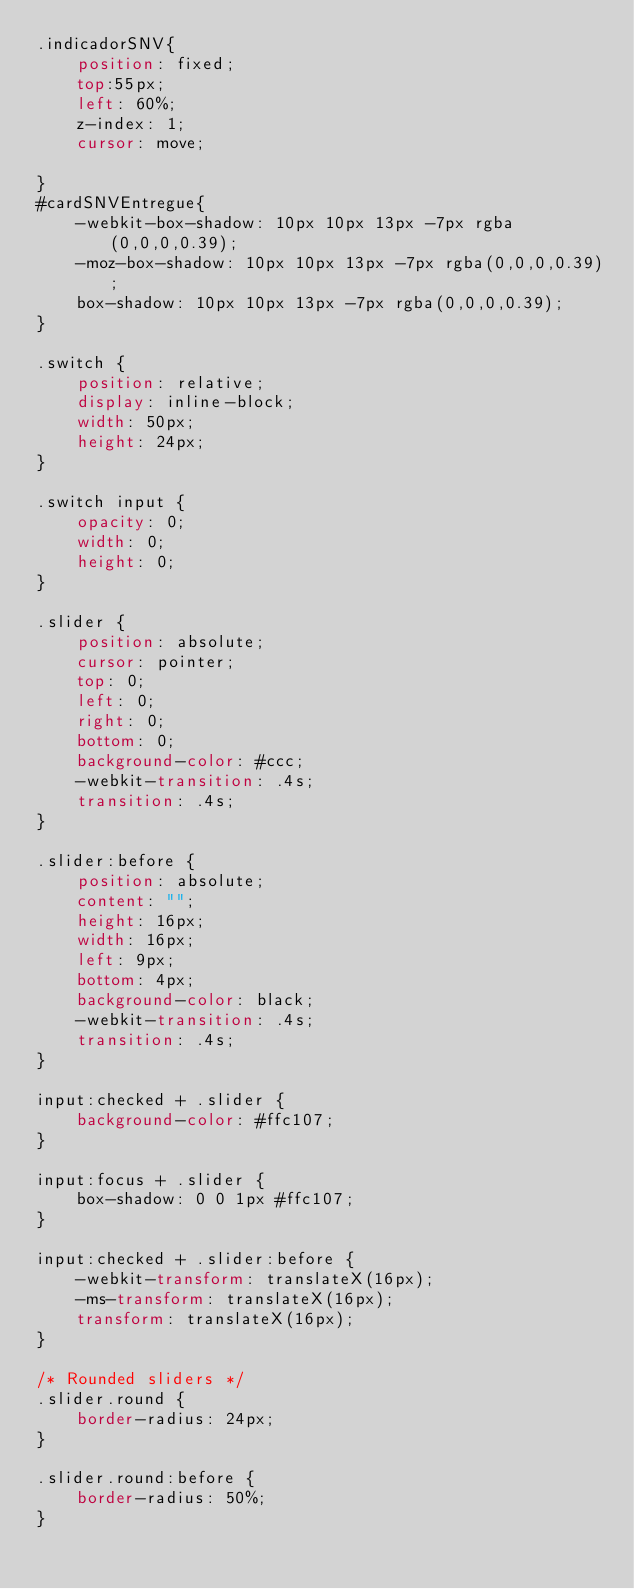<code> <loc_0><loc_0><loc_500><loc_500><_CSS_>.indicadorSNV{
    position: fixed;
    top:55px;
    left: 60%;
    z-index: 1;
    cursor: move;

}
#cardSNVEntregue{
    -webkit-box-shadow: 10px 10px 13px -7px rgba(0,0,0,0.39);
    -moz-box-shadow: 10px 10px 13px -7px rgba(0,0,0,0.39);
    box-shadow: 10px 10px 13px -7px rgba(0,0,0,0.39);
}

.switch {
    position: relative;
    display: inline-block;
    width: 50px;
    height: 24px;
}

.switch input {
    opacity: 0;
    width: 0;
    height: 0;
}

.slider {
    position: absolute;
    cursor: pointer;
    top: 0;
    left: 0;
    right: 0;
    bottom: 0;
    background-color: #ccc;
    -webkit-transition: .4s;
    transition: .4s;
}

.slider:before {
    position: absolute;
    content: "";
    height: 16px;
    width: 16px;
    left: 9px;
    bottom: 4px;
    background-color: black;
    -webkit-transition: .4s;
    transition: .4s;
}

input:checked + .slider {
    background-color: #ffc107;
}

input:focus + .slider {
    box-shadow: 0 0 1px #ffc107;
}

input:checked + .slider:before {
    -webkit-transform: translateX(16px);
    -ms-transform: translateX(16px);
    transform: translateX(16px);
}

/* Rounded sliders */
.slider.round {
    border-radius: 24px;
}

.slider.round:before {
    border-radius: 50%;
}</code> 